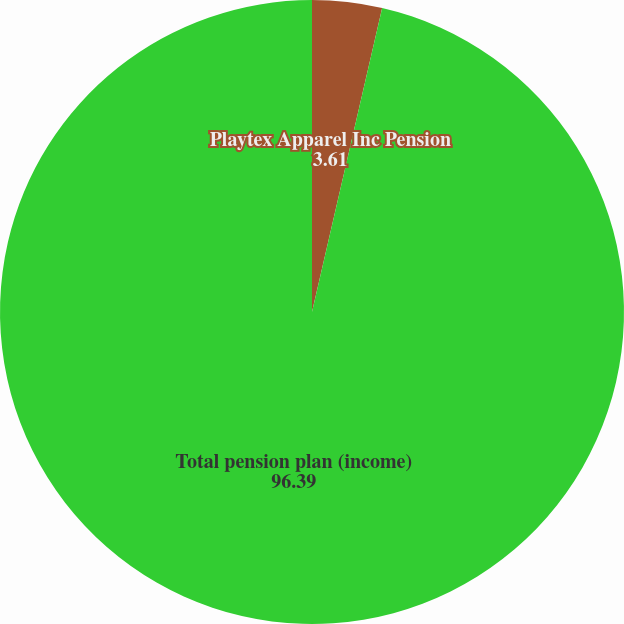Convert chart to OTSL. <chart><loc_0><loc_0><loc_500><loc_500><pie_chart><fcel>Playtex Apparel Inc Pension<fcel>Total pension plan (income)<nl><fcel>3.61%<fcel>96.39%<nl></chart> 